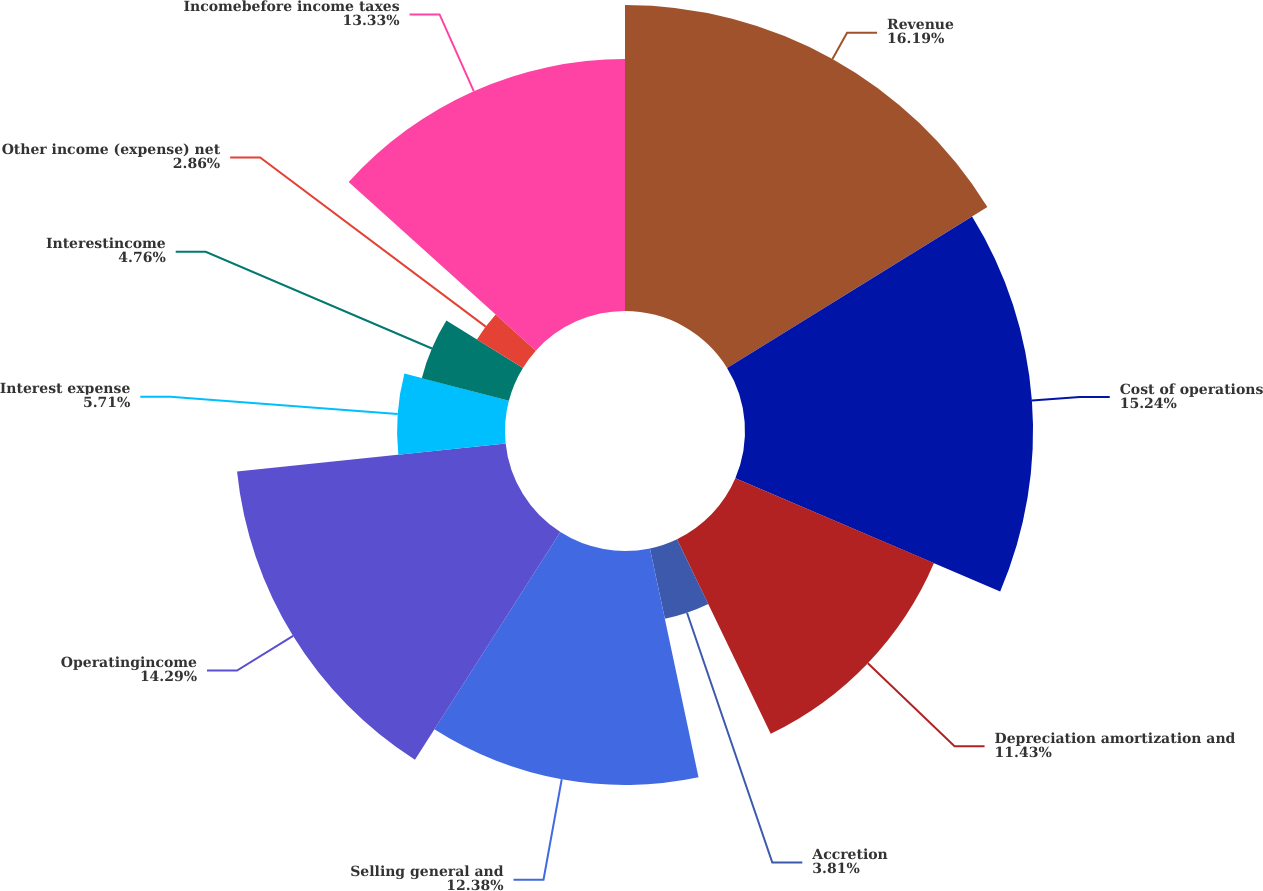Convert chart. <chart><loc_0><loc_0><loc_500><loc_500><pie_chart><fcel>Revenue<fcel>Cost of operations<fcel>Depreciation amortization and<fcel>Accretion<fcel>Selling general and<fcel>Operatingincome<fcel>Interest expense<fcel>Interestincome<fcel>Other income (expense) net<fcel>Incomebefore income taxes<nl><fcel>16.19%<fcel>15.24%<fcel>11.43%<fcel>3.81%<fcel>12.38%<fcel>14.29%<fcel>5.71%<fcel>4.76%<fcel>2.86%<fcel>13.33%<nl></chart> 